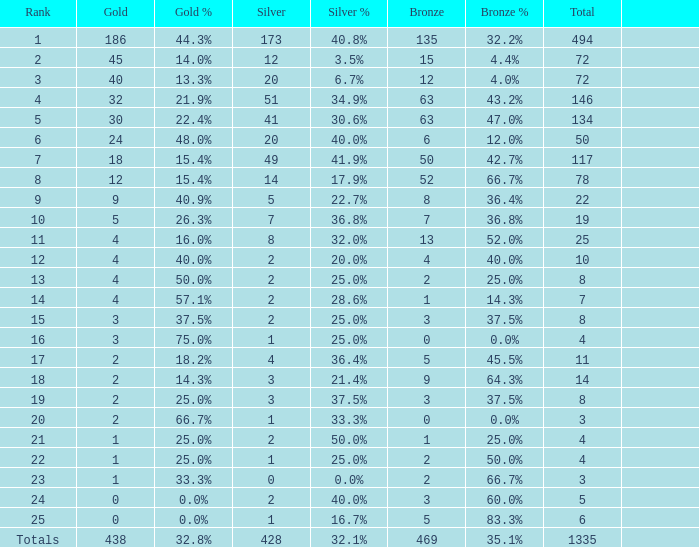Can you parse all the data within this table? {'header': ['Rank', 'Gold', 'Gold %', 'Silver', 'Silver %', 'Bronze', 'Bronze %', 'Total', ''], 'rows': [['1', '186', '44.3%', '173', '40.8%', '135', '32.2%', '494', ''], ['2', '45', '14.0%', '12', '3.5%', '15', '4.4%', '72', ''], ['3', '40', '13.3%', '20', '6.7%', '12', '4.0%', '72', ''], ['4', '32', '21.9%', '51', '34.9%', '63', '43.2%', '146', ''], ['5', '30', '22.4%', '41', '30.6%', '63', '47.0%', '134', ''], ['6', '24', '48.0%', '20', '40.0%', '6', '12.0%', '50', ''], ['7', '18', '15.4%', '49', '41.9%', '50', '42.7%', '117', ''], ['8', '12', '15.4%', '14', '17.9%', '52', '66.7%', '78', ''], ['9', '9', '40.9%', '5', '22.7%', '8', '36.4%', '22', ''], ['10', '5', '26.3%', '7', '36.8%', '7', '36.8%', '19', ''], ['11', '4', '16.0%', '8', '32.0%', '13', '52.0%', '25', ''], ['12', '4', '40.0%', '2', '20.0%', '4', '40.0%', '10', ''], ['13', '4', '50.0%', '2', '25.0%', '2', '25.0%', '8', ''], ['14', '4', '57.1%', '2', '28.6%', '1', '14.3%', '7', ''], ['15', '3', '37.5%', '2', '25.0%', '3', '37.5%', '8', ''], ['16', '3', '75.0%', '1', '25.0%', '0', '0.0%', '4', ''], ['17', '2', '18.2%', '4', '36.4%', '5', '45.5%', '11', ''], ['18', '2', '14.3%', '3', '21.4%', '9', '64.3%', '14', ''], ['19', '2', '25.0%', '3', '37.5%', '3', '37.5%', '8', ''], ['20', '2', '66.7%', '1', '33.3%', '0', '0.0%', '3', ''], ['21', '1', '25.0%', '2', '50.0%', '1', '25.0%', '4', ''], ['22', '1', '25.0%', '1', '25.0%', '2', '50.0%', '4', ''], ['23', '1', '33.3%', '0', '0.0%', '2', '66.7%', '3', ''], ['24', '0', '0.0%', '2', '40.0%', '3', '60.0%', '5', ''], ['25', '0', '0.0%', '1', '16.7%', '5', '83.3%', '6', ''], ['Totals', '438', '32.8%', '428', '32.1%', '469', '35.1%', '1335', '']]} What is the number of bronze medals when the total medals were 78 and there were less than 12 golds? None. 